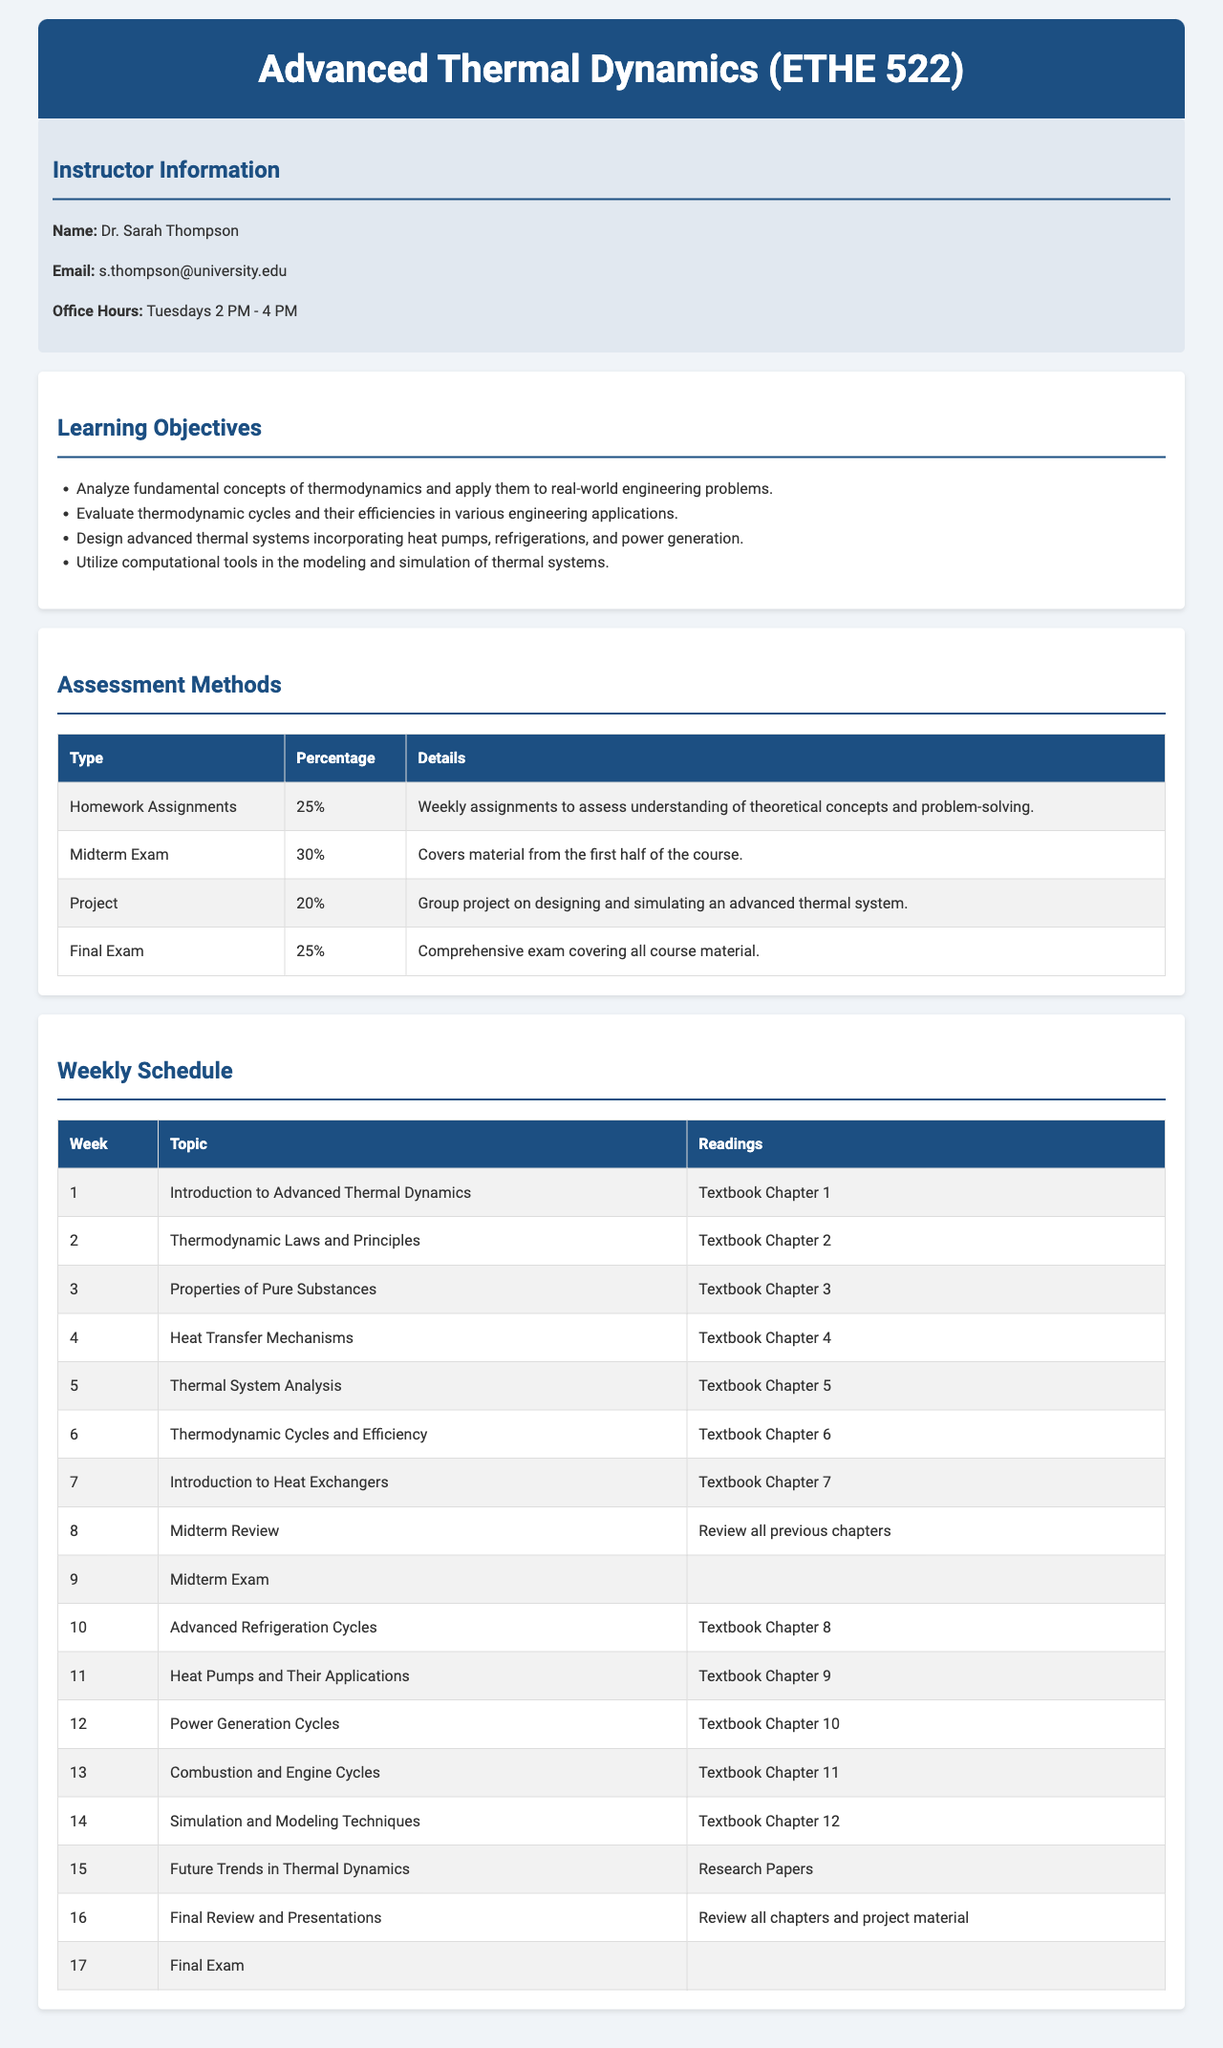What is the course title? The course title is specified in the header of the document, indicating the subject being taught.
Answer: Advanced Thermal Dynamics (ETHE 522) Who is the instructor for the course? The instructor's information section provides the name of the person teaching the course.
Answer: Dr. Sarah Thompson What is the percentage weight of the Midterm Exam? The assessment methods table details the weight assigned to each component of the evaluation, including the midterm exam.
Answer: 30% How many weeks are dedicated to the course schedule? The weekly schedule section consists of multiple rows, each representing a week. Counting these gives the total number of weeks.
Answer: 17 weeks What is one of the learning objectives of the course? The learning objectives section lists the goals for the students upon completing the course, requiring the extraction of one specific goal.
Answer: Analyze fundamental concepts of thermodynamics and apply them to real-world engineering problems Which week covers "Thermal System Analysis"? The weekly schedule outlines the topics planned for each week of the course, allowing identification of the week related to the specified topic.
Answer: Week 5 What type of project is included in the assessment methods? The assessment methods table describes the nature of the project that students will be involved in during the course.
Answer: Group project on designing and simulating an advanced thermal system Which chapter is reviewed during the Midterm Review week? The weekly schedule includes instructions on what to review during the midterm week, detailing the learning materials covered.
Answer: Review all previous chapters What are the readings for Week 10? The weekly schedule specifically notes the readings assigned for each week, indicating what students are expected to study.
Answer: Textbook Chapter 8 